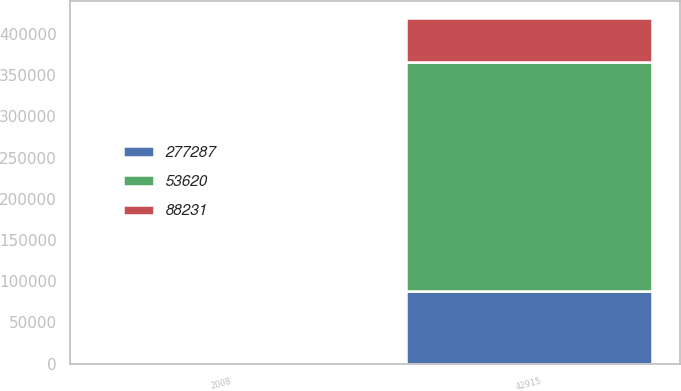Convert chart. <chart><loc_0><loc_0><loc_500><loc_500><stacked_bar_chart><ecel><fcel>2008<fcel>42915<nl><fcel>88231<fcel>2007<fcel>53620<nl><fcel>277287<fcel>2006<fcel>88231<nl><fcel>53620<fcel>2005<fcel>277287<nl></chart> 